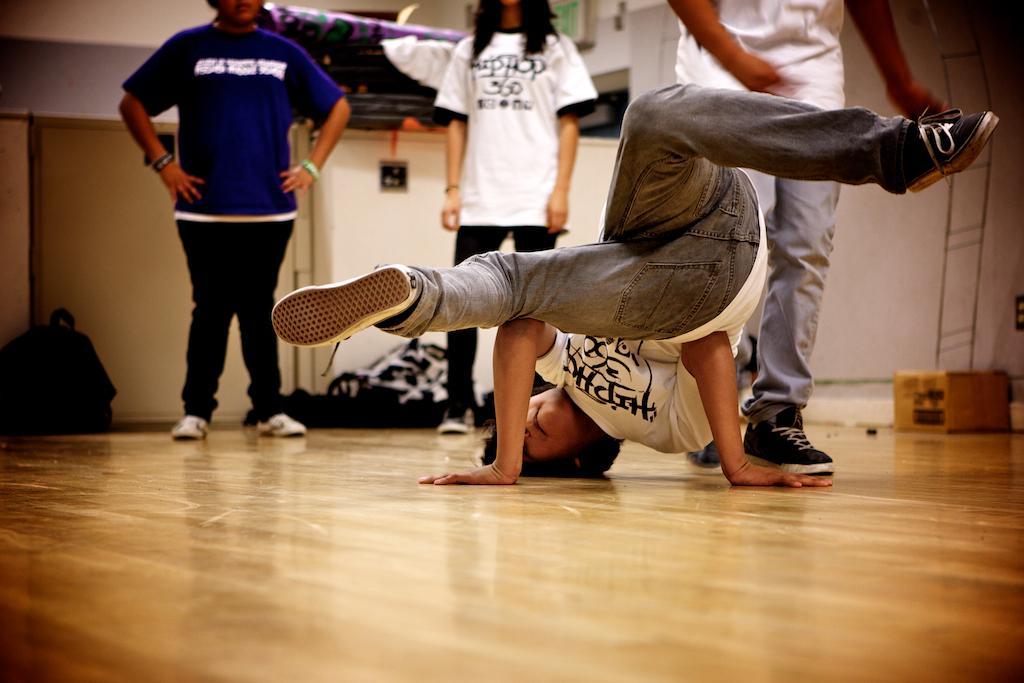Could you give a brief overview of what you see in this image? In this image there is a floor. A person is dancing. There are other people standing. There is a box on the right side. There are bags in the background. There is a wall. 